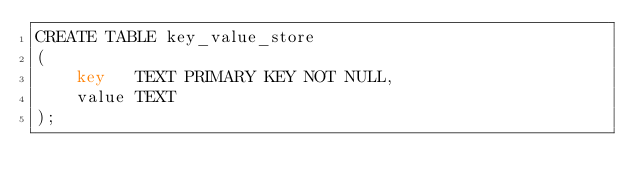Convert code to text. <code><loc_0><loc_0><loc_500><loc_500><_SQL_>CREATE TABLE key_value_store
(
    key   TEXT PRIMARY KEY NOT NULL,
    value TEXT
);
</code> 